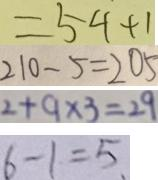<formula> <loc_0><loc_0><loc_500><loc_500>= 5 4 + 1 
 2 1 0 - 5 = 2 0 5 
 2 + 9 \times 3 = 2 9 
 6 - 1 = 5 .</formula> 